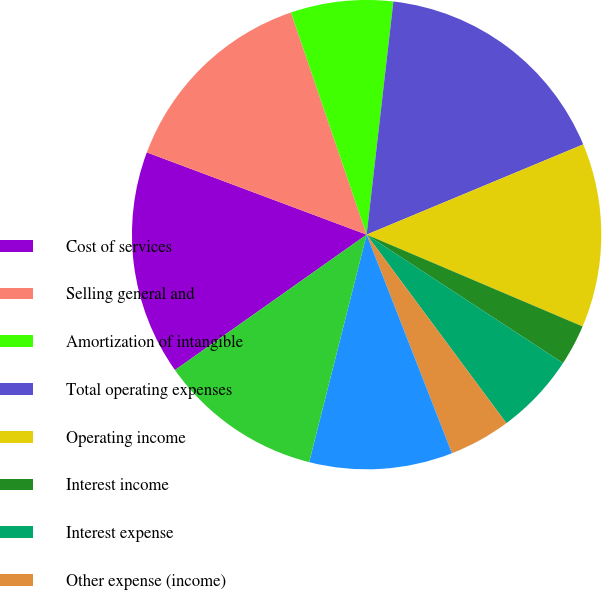Convert chart to OTSL. <chart><loc_0><loc_0><loc_500><loc_500><pie_chart><fcel>Cost of services<fcel>Selling general and<fcel>Amortization of intangible<fcel>Total operating expenses<fcel>Operating income<fcel>Interest income<fcel>Interest expense<fcel>Other expense (income)<fcel>Interest expense (income) and<fcel>Income before provision for<nl><fcel>15.49%<fcel>14.08%<fcel>7.04%<fcel>16.9%<fcel>12.68%<fcel>2.82%<fcel>5.63%<fcel>4.23%<fcel>9.86%<fcel>11.27%<nl></chart> 